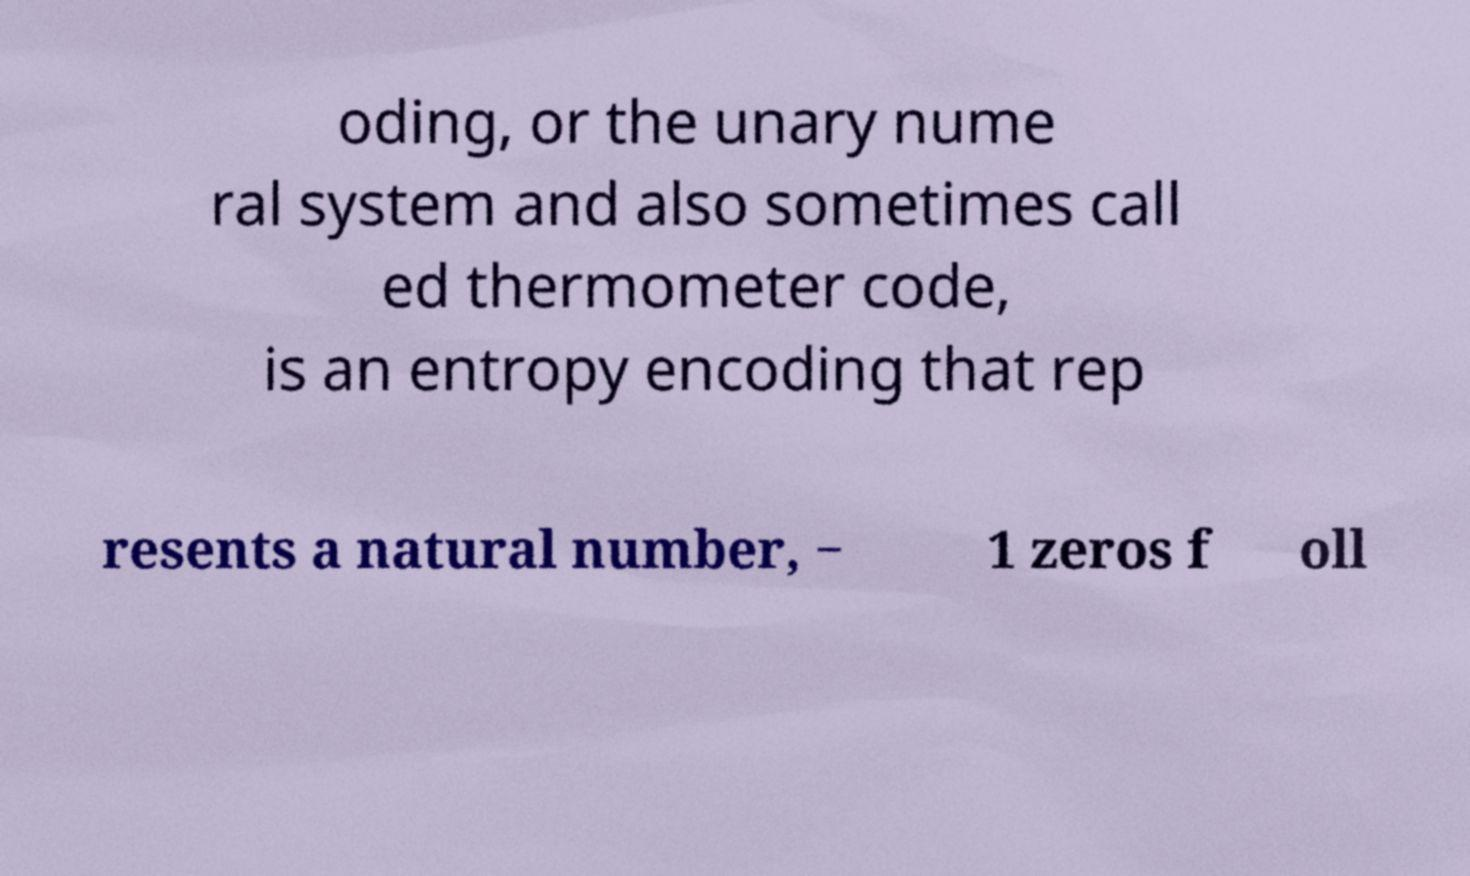Could you extract and type out the text from this image? oding, or the unary nume ral system and also sometimes call ed thermometer code, is an entropy encoding that rep resents a natural number, − 1 zeros f oll 